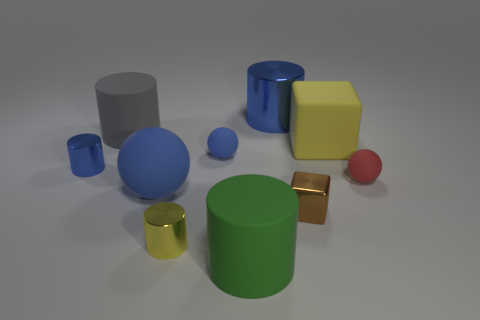Is there any other thing that has the same size as the yellow shiny object?
Keep it short and to the point. Yes. How many rubber objects are either green things or red things?
Provide a short and direct response. 2. Is there a large rubber block?
Keep it short and to the point. Yes. There is a big cylinder in front of the sphere to the right of the green matte cylinder; what is its color?
Offer a very short reply. Green. How many other things are the same color as the large rubber cube?
Keep it short and to the point. 1. What number of objects are small red matte balls or matte cylinders right of the small blue rubber object?
Your answer should be very brief. 2. What color is the metallic cylinder that is in front of the tiny blue metallic cylinder?
Ensure brevity in your answer.  Yellow. What is the shape of the big gray matte thing?
Your response must be concise. Cylinder. What material is the tiny ball that is to the right of the cube behind the red ball?
Ensure brevity in your answer.  Rubber. How many other things are there of the same material as the tiny red object?
Provide a succinct answer. 5. 